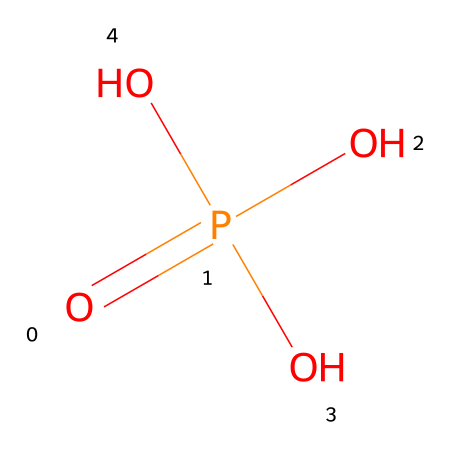What is the name of this chemical? The SMILES representation refers to a compound with a phosphorus atom bonded to four oxygen atoms. This is characteristic of phosphoric acid.
Answer: phosphoric acid How many oxygen atoms are present in this compound? By examining the SMILES structure, there are three oxygen atoms directly bonded to phosphorus and one double-bonded oxygen, totaling four oxygen atoms.
Answer: four What type of bond connects phosphorus to oxygen in this compound? The SMILES shows that one oxygen is double-bonded to phosphorus, while the other three are single-bonded. Therefore, there are both double and single bonds present.
Answer: double and single bonds What is the oxidation state of phosphorus in this compound? In this structure, phosphorus is bonded to four oxygen atoms, where the oxidation state can be calculated. The typical oxidation state for phosphorus in phosphoric acid is +5.
Answer: +5 What type of chemical is this compound classified as? This compound has multiple hydroxyl (–OH) groups attached to the phosphorus, which classifies it as an acid, specifically an organophosphate.
Answer: organophosphate What role does this compound play as a corrosion inhibitor? Phosphoric acid forms a protective phosphoric layer on metal surfaces, which prevents corrosion by inhibiting electrochemical reactions on the metal.
Answer: protective layer 